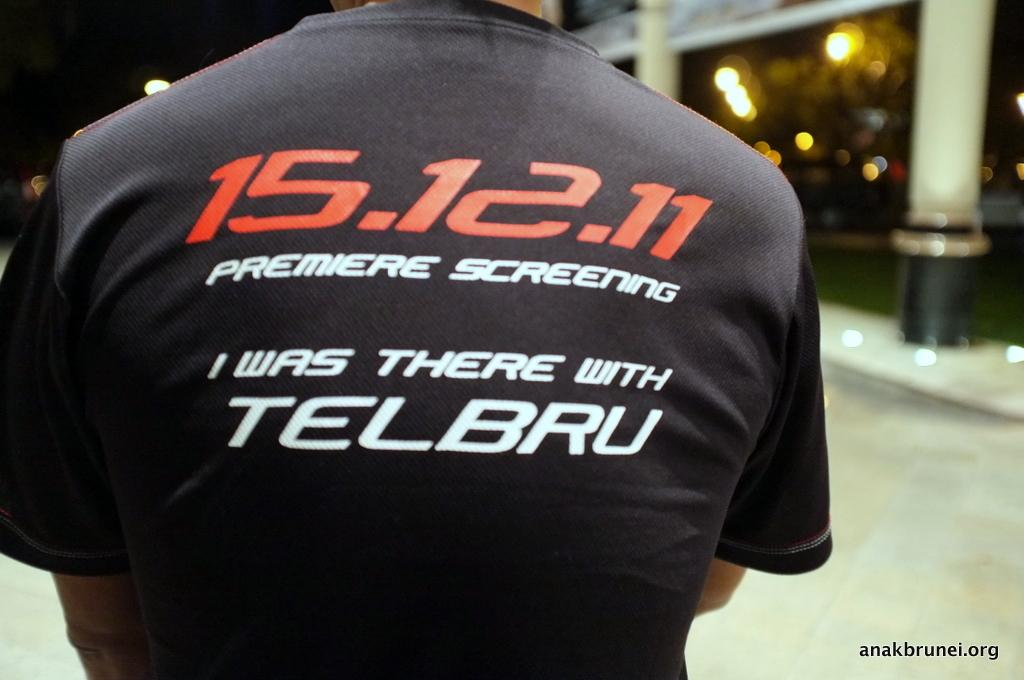<image>
Provide a brief description of the given image. some numbers that say 15.12.11 on the shirt 